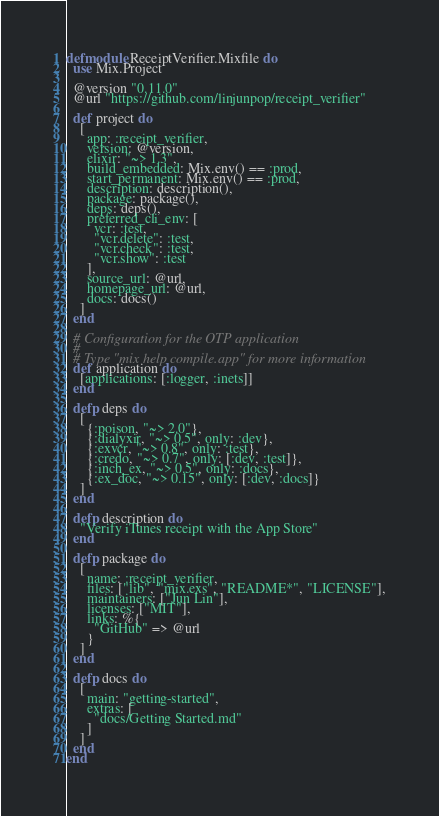<code> <loc_0><loc_0><loc_500><loc_500><_Elixir_>defmodule ReceiptVerifier.Mixfile do
  use Mix.Project

  @version "0.11.0"
  @url "https://github.com/linjunpop/receipt_verifier"

  def project do
    [
      app: :receipt_verifier,
      version: @version,
      elixir: "~> 1.3",
      build_embedded: Mix.env() == :prod,
      start_permanent: Mix.env() == :prod,
      description: description(),
      package: package(),
      deps: deps(),
      preferred_cli_env: [
        vcr: :test,
        "vcr.delete": :test,
        "vcr.check": :test,
        "vcr.show": :test
      ],
      source_url: @url,
      homepage_url: @url,
      docs: docs()
    ]
  end

  # Configuration for the OTP application
  #
  # Type "mix help compile.app" for more information
  def application do
    [applications: [:logger, :inets]]
  end

  defp deps do
    [
      {:poison, "~> 2.0"},
      {:dialyxir, "~> 0.5", only: :dev},
      {:exvcr, "~> 0.8", only: :test},
      {:credo, "~> 0.7", only: [:dev, :test]},
      {:inch_ex, "~> 0.5", only: :docs},
      {:ex_doc, "~> 0.15", only: [:dev, :docs]}
    ]
  end

  defp description do
    "Verify iTunes receipt with the App Store"
  end

  defp package do
    [
      name: :receipt_verifier,
      files: ["lib", "mix.exs", "README*", "LICENSE"],
      maintainers: ["Jun Lin"],
      licenses: ["MIT"],
      links: %{
        "GitHub" => @url
      }
    ]
  end

  defp docs do
    [
      main: "getting-started",
      extras: [
        "docs/Getting Started.md"
      ]
    ]
  end
end
</code> 